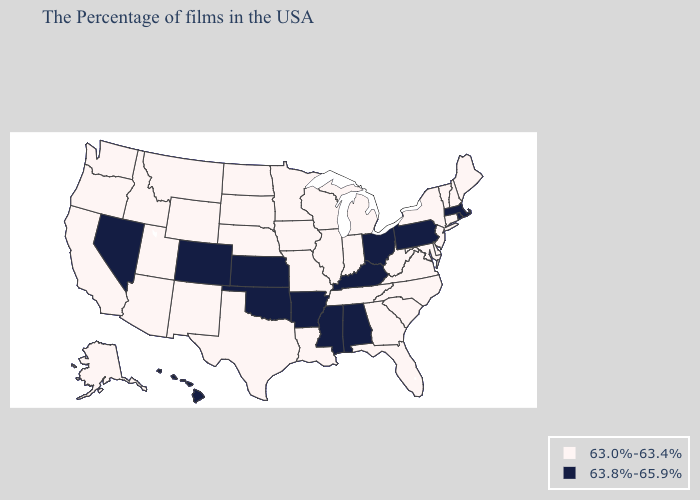Among the states that border Minnesota , which have the lowest value?
Answer briefly. Wisconsin, Iowa, South Dakota, North Dakota. Name the states that have a value in the range 63.8%-65.9%?
Give a very brief answer. Massachusetts, Rhode Island, Pennsylvania, Ohio, Kentucky, Alabama, Mississippi, Arkansas, Kansas, Oklahoma, Colorado, Nevada, Hawaii. Name the states that have a value in the range 63.8%-65.9%?
Answer briefly. Massachusetts, Rhode Island, Pennsylvania, Ohio, Kentucky, Alabama, Mississippi, Arkansas, Kansas, Oklahoma, Colorado, Nevada, Hawaii. Name the states that have a value in the range 63.0%-63.4%?
Quick response, please. Maine, New Hampshire, Vermont, Connecticut, New York, New Jersey, Delaware, Maryland, Virginia, North Carolina, South Carolina, West Virginia, Florida, Georgia, Michigan, Indiana, Tennessee, Wisconsin, Illinois, Louisiana, Missouri, Minnesota, Iowa, Nebraska, Texas, South Dakota, North Dakota, Wyoming, New Mexico, Utah, Montana, Arizona, Idaho, California, Washington, Oregon, Alaska. Does Oregon have the same value as North Dakota?
Answer briefly. Yes. Which states have the lowest value in the West?
Give a very brief answer. Wyoming, New Mexico, Utah, Montana, Arizona, Idaho, California, Washington, Oregon, Alaska. Among the states that border Missouri , which have the lowest value?
Quick response, please. Tennessee, Illinois, Iowa, Nebraska. Does Pennsylvania have the lowest value in the USA?
Keep it brief. No. What is the value of Wyoming?
Be succinct. 63.0%-63.4%. Among the states that border Nebraska , which have the highest value?
Concise answer only. Kansas, Colorado. Does Utah have the same value as Missouri?
Answer briefly. Yes. What is the value of New Jersey?
Answer briefly. 63.0%-63.4%. Does Ohio have the same value as Massachusetts?
Be succinct. Yes. 